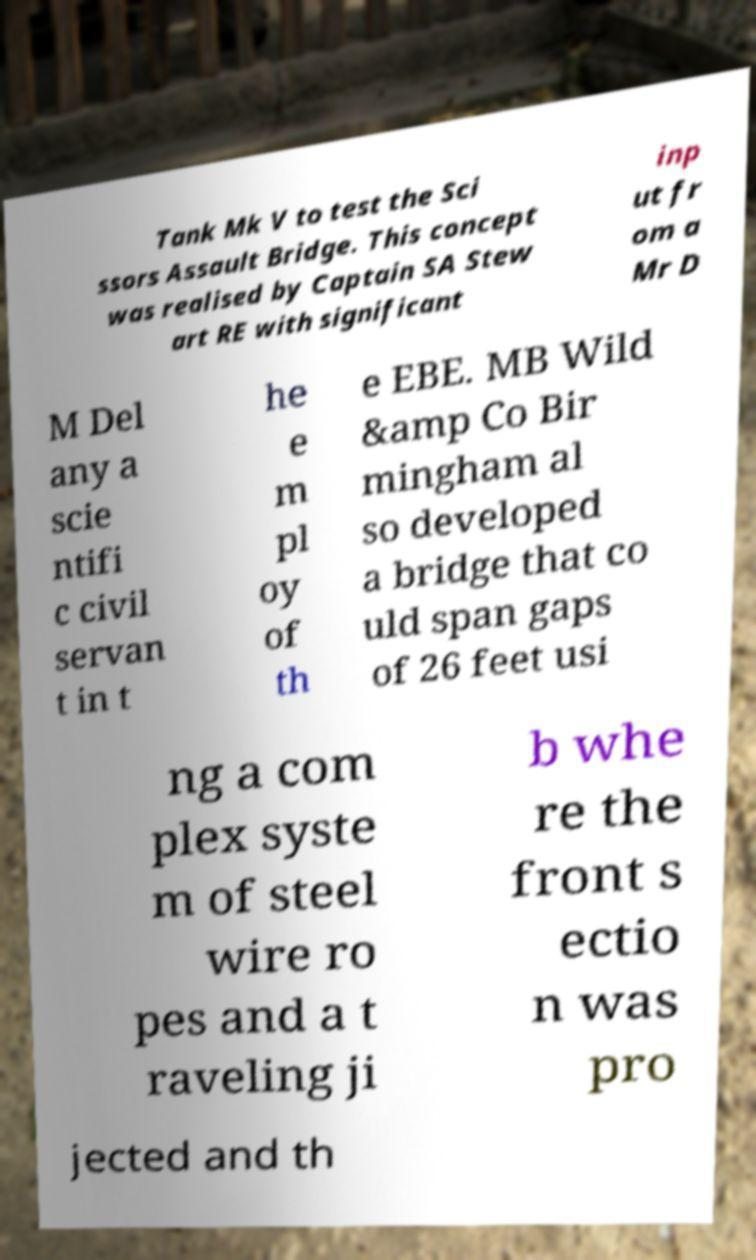There's text embedded in this image that I need extracted. Can you transcribe it verbatim? Tank Mk V to test the Sci ssors Assault Bridge. This concept was realised by Captain SA Stew art RE with significant inp ut fr om a Mr D M Del any a scie ntifi c civil servan t in t he e m pl oy of th e EBE. MB Wild &amp Co Bir mingham al so developed a bridge that co uld span gaps of 26 feet usi ng a com plex syste m of steel wire ro pes and a t raveling ji b whe re the front s ectio n was pro jected and th 